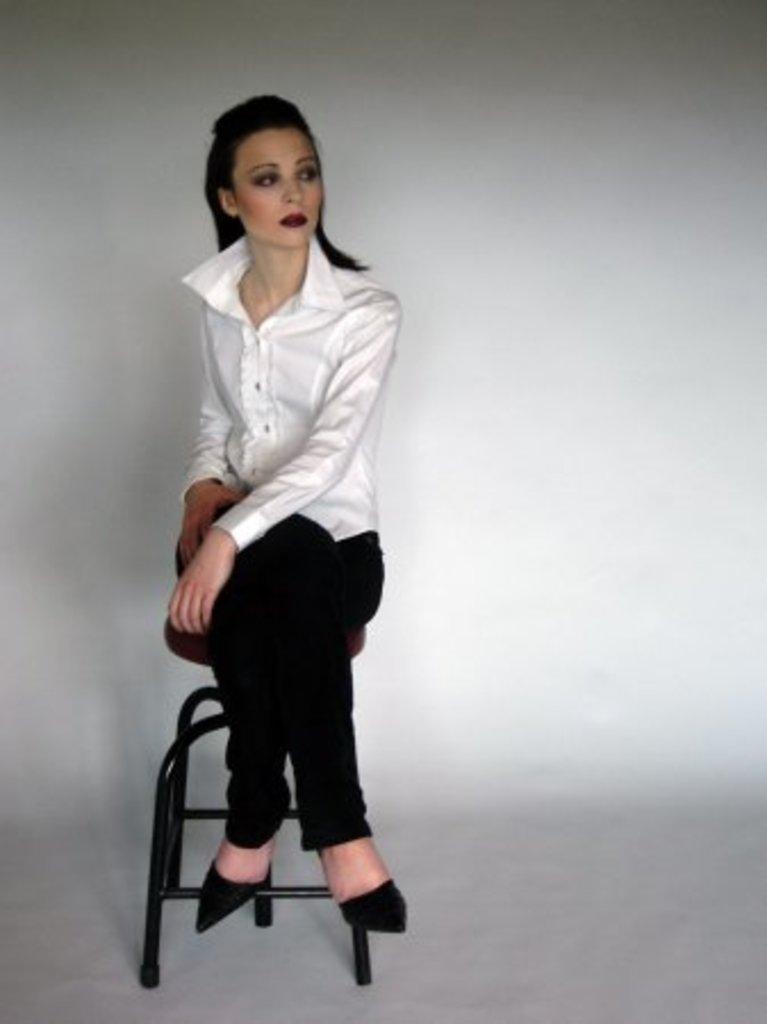How would you summarize this image in a sentence or two? In this image I can see a person sitting on the chair. 